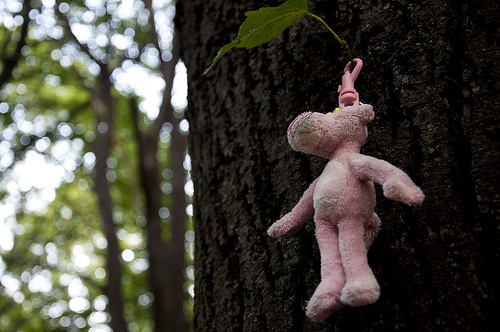<image>
Is the panther under the leaf? Yes. The panther is positioned underneath the leaf, with the leaf above it in the vertical space. Is there a toy under the tree? No. The toy is not positioned under the tree. The vertical relationship between these objects is different. Is there a bear in the tree? Yes. The bear is contained within or inside the tree, showing a containment relationship. Where is the horse doll in relation to the teak wood? Is it in the teak wood? No. The horse doll is not contained within the teak wood. These objects have a different spatial relationship. 